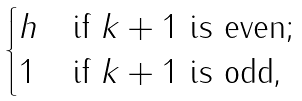<formula> <loc_0><loc_0><loc_500><loc_500>\begin{cases} h & \text {if $k+1$ is even;} \\ 1 & \text {if $k+1$ is odd,} \end{cases}</formula> 